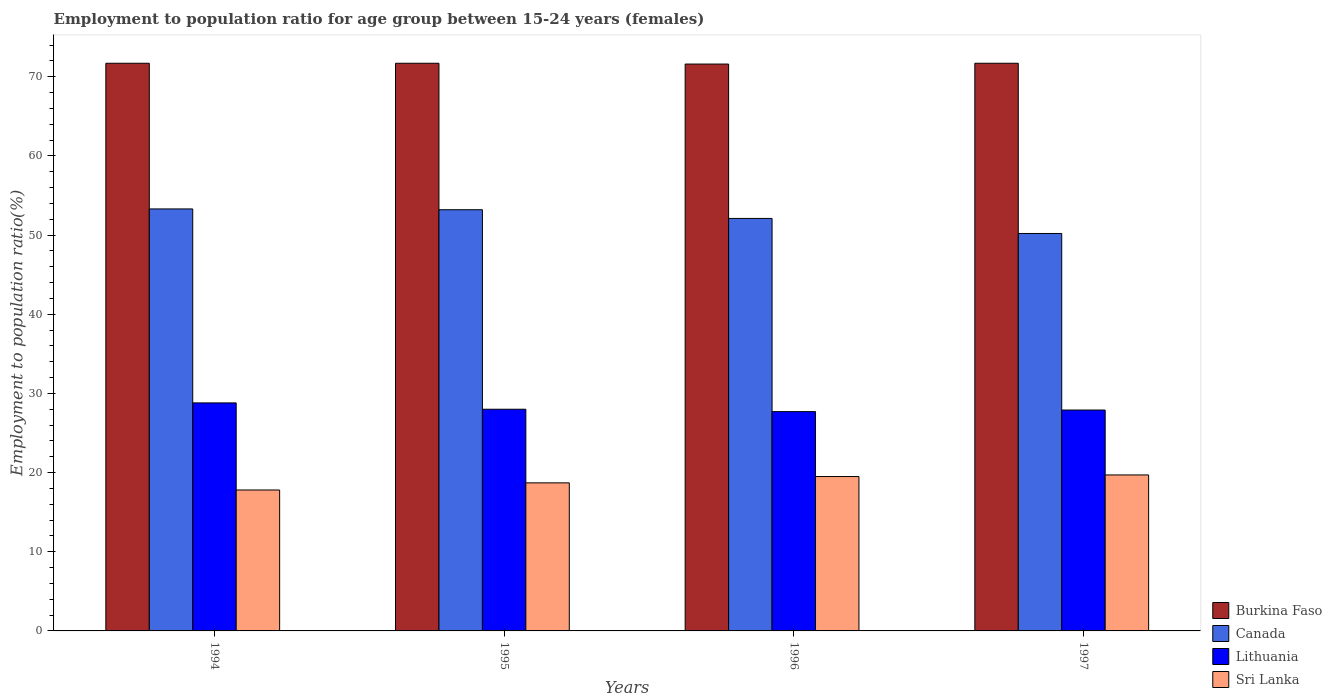Are the number of bars per tick equal to the number of legend labels?
Make the answer very short. Yes. How many bars are there on the 2nd tick from the right?
Make the answer very short. 4. What is the label of the 3rd group of bars from the left?
Keep it short and to the point. 1996. What is the employment to population ratio in Canada in 1995?
Offer a very short reply. 53.2. Across all years, what is the maximum employment to population ratio in Burkina Faso?
Provide a succinct answer. 71.7. Across all years, what is the minimum employment to population ratio in Sri Lanka?
Your answer should be compact. 17.8. In which year was the employment to population ratio in Burkina Faso maximum?
Provide a short and direct response. 1994. In which year was the employment to population ratio in Sri Lanka minimum?
Offer a very short reply. 1994. What is the total employment to population ratio in Lithuania in the graph?
Make the answer very short. 112.4. What is the difference between the employment to population ratio in Burkina Faso in 1995 and that in 1997?
Your answer should be very brief. 0. What is the difference between the employment to population ratio in Burkina Faso in 1997 and the employment to population ratio in Sri Lanka in 1995?
Your answer should be very brief. 53. What is the average employment to population ratio in Lithuania per year?
Keep it short and to the point. 28.1. In the year 1996, what is the difference between the employment to population ratio in Burkina Faso and employment to population ratio in Lithuania?
Keep it short and to the point. 43.9. What is the ratio of the employment to population ratio in Sri Lanka in 1994 to that in 1995?
Your answer should be compact. 0.95. What is the difference between the highest and the second highest employment to population ratio in Lithuania?
Keep it short and to the point. 0.8. What is the difference between the highest and the lowest employment to population ratio in Canada?
Make the answer very short. 3.1. Is the sum of the employment to population ratio in Burkina Faso in 1995 and 1996 greater than the maximum employment to population ratio in Sri Lanka across all years?
Offer a terse response. Yes. Is it the case that in every year, the sum of the employment to population ratio in Canada and employment to population ratio in Burkina Faso is greater than the sum of employment to population ratio in Sri Lanka and employment to population ratio in Lithuania?
Offer a very short reply. Yes. What does the 4th bar from the right in 1996 represents?
Ensure brevity in your answer.  Burkina Faso. Are all the bars in the graph horizontal?
Ensure brevity in your answer.  No. Are the values on the major ticks of Y-axis written in scientific E-notation?
Offer a terse response. No. Does the graph contain any zero values?
Ensure brevity in your answer.  No. Does the graph contain grids?
Give a very brief answer. No. Where does the legend appear in the graph?
Provide a short and direct response. Bottom right. How are the legend labels stacked?
Keep it short and to the point. Vertical. What is the title of the graph?
Keep it short and to the point. Employment to population ratio for age group between 15-24 years (females). What is the label or title of the Y-axis?
Provide a short and direct response. Employment to population ratio(%). What is the Employment to population ratio(%) in Burkina Faso in 1994?
Offer a terse response. 71.7. What is the Employment to population ratio(%) of Canada in 1994?
Your response must be concise. 53.3. What is the Employment to population ratio(%) in Lithuania in 1994?
Ensure brevity in your answer.  28.8. What is the Employment to population ratio(%) of Sri Lanka in 1994?
Keep it short and to the point. 17.8. What is the Employment to population ratio(%) of Burkina Faso in 1995?
Your answer should be very brief. 71.7. What is the Employment to population ratio(%) of Canada in 1995?
Your response must be concise. 53.2. What is the Employment to population ratio(%) in Sri Lanka in 1995?
Your answer should be compact. 18.7. What is the Employment to population ratio(%) in Burkina Faso in 1996?
Provide a short and direct response. 71.6. What is the Employment to population ratio(%) in Canada in 1996?
Your answer should be compact. 52.1. What is the Employment to population ratio(%) of Lithuania in 1996?
Provide a short and direct response. 27.7. What is the Employment to population ratio(%) in Sri Lanka in 1996?
Keep it short and to the point. 19.5. What is the Employment to population ratio(%) of Burkina Faso in 1997?
Give a very brief answer. 71.7. What is the Employment to population ratio(%) in Canada in 1997?
Make the answer very short. 50.2. What is the Employment to population ratio(%) in Lithuania in 1997?
Ensure brevity in your answer.  27.9. What is the Employment to population ratio(%) in Sri Lanka in 1997?
Your response must be concise. 19.7. Across all years, what is the maximum Employment to population ratio(%) in Burkina Faso?
Your response must be concise. 71.7. Across all years, what is the maximum Employment to population ratio(%) of Canada?
Keep it short and to the point. 53.3. Across all years, what is the maximum Employment to population ratio(%) in Lithuania?
Your answer should be very brief. 28.8. Across all years, what is the maximum Employment to population ratio(%) of Sri Lanka?
Provide a succinct answer. 19.7. Across all years, what is the minimum Employment to population ratio(%) of Burkina Faso?
Provide a succinct answer. 71.6. Across all years, what is the minimum Employment to population ratio(%) of Canada?
Offer a terse response. 50.2. Across all years, what is the minimum Employment to population ratio(%) in Lithuania?
Provide a succinct answer. 27.7. Across all years, what is the minimum Employment to population ratio(%) of Sri Lanka?
Give a very brief answer. 17.8. What is the total Employment to population ratio(%) in Burkina Faso in the graph?
Your answer should be compact. 286.7. What is the total Employment to population ratio(%) of Canada in the graph?
Your answer should be very brief. 208.8. What is the total Employment to population ratio(%) of Lithuania in the graph?
Provide a short and direct response. 112.4. What is the total Employment to population ratio(%) in Sri Lanka in the graph?
Provide a succinct answer. 75.7. What is the difference between the Employment to population ratio(%) in Canada in 1994 and that in 1995?
Offer a very short reply. 0.1. What is the difference between the Employment to population ratio(%) of Lithuania in 1994 and that in 1995?
Your response must be concise. 0.8. What is the difference between the Employment to population ratio(%) in Burkina Faso in 1994 and that in 1996?
Give a very brief answer. 0.1. What is the difference between the Employment to population ratio(%) in Burkina Faso in 1994 and that in 1997?
Offer a terse response. 0. What is the difference between the Employment to population ratio(%) in Canada in 1994 and that in 1997?
Ensure brevity in your answer.  3.1. What is the difference between the Employment to population ratio(%) in Sri Lanka in 1994 and that in 1997?
Offer a terse response. -1.9. What is the difference between the Employment to population ratio(%) in Burkina Faso in 1995 and that in 1996?
Ensure brevity in your answer.  0.1. What is the difference between the Employment to population ratio(%) of Sri Lanka in 1995 and that in 1997?
Your response must be concise. -1. What is the difference between the Employment to population ratio(%) in Burkina Faso in 1996 and that in 1997?
Offer a very short reply. -0.1. What is the difference between the Employment to population ratio(%) in Burkina Faso in 1994 and the Employment to population ratio(%) in Lithuania in 1995?
Make the answer very short. 43.7. What is the difference between the Employment to population ratio(%) in Burkina Faso in 1994 and the Employment to population ratio(%) in Sri Lanka in 1995?
Offer a terse response. 53. What is the difference between the Employment to population ratio(%) in Canada in 1994 and the Employment to population ratio(%) in Lithuania in 1995?
Give a very brief answer. 25.3. What is the difference between the Employment to population ratio(%) of Canada in 1994 and the Employment to population ratio(%) of Sri Lanka in 1995?
Provide a succinct answer. 34.6. What is the difference between the Employment to population ratio(%) of Burkina Faso in 1994 and the Employment to population ratio(%) of Canada in 1996?
Your response must be concise. 19.6. What is the difference between the Employment to population ratio(%) in Burkina Faso in 1994 and the Employment to population ratio(%) in Sri Lanka in 1996?
Your answer should be very brief. 52.2. What is the difference between the Employment to population ratio(%) in Canada in 1994 and the Employment to population ratio(%) in Lithuania in 1996?
Keep it short and to the point. 25.6. What is the difference between the Employment to population ratio(%) of Canada in 1994 and the Employment to population ratio(%) of Sri Lanka in 1996?
Your answer should be very brief. 33.8. What is the difference between the Employment to population ratio(%) of Lithuania in 1994 and the Employment to population ratio(%) of Sri Lanka in 1996?
Your response must be concise. 9.3. What is the difference between the Employment to population ratio(%) of Burkina Faso in 1994 and the Employment to population ratio(%) of Lithuania in 1997?
Give a very brief answer. 43.8. What is the difference between the Employment to population ratio(%) in Canada in 1994 and the Employment to population ratio(%) in Lithuania in 1997?
Offer a very short reply. 25.4. What is the difference between the Employment to population ratio(%) in Canada in 1994 and the Employment to population ratio(%) in Sri Lanka in 1997?
Offer a very short reply. 33.6. What is the difference between the Employment to population ratio(%) in Burkina Faso in 1995 and the Employment to population ratio(%) in Canada in 1996?
Provide a short and direct response. 19.6. What is the difference between the Employment to population ratio(%) of Burkina Faso in 1995 and the Employment to population ratio(%) of Lithuania in 1996?
Your answer should be compact. 44. What is the difference between the Employment to population ratio(%) in Burkina Faso in 1995 and the Employment to population ratio(%) in Sri Lanka in 1996?
Keep it short and to the point. 52.2. What is the difference between the Employment to population ratio(%) of Canada in 1995 and the Employment to population ratio(%) of Sri Lanka in 1996?
Your answer should be compact. 33.7. What is the difference between the Employment to population ratio(%) in Lithuania in 1995 and the Employment to population ratio(%) in Sri Lanka in 1996?
Give a very brief answer. 8.5. What is the difference between the Employment to population ratio(%) of Burkina Faso in 1995 and the Employment to population ratio(%) of Canada in 1997?
Ensure brevity in your answer.  21.5. What is the difference between the Employment to population ratio(%) of Burkina Faso in 1995 and the Employment to population ratio(%) of Lithuania in 1997?
Provide a succinct answer. 43.8. What is the difference between the Employment to population ratio(%) in Canada in 1995 and the Employment to population ratio(%) in Lithuania in 1997?
Keep it short and to the point. 25.3. What is the difference between the Employment to population ratio(%) in Canada in 1995 and the Employment to population ratio(%) in Sri Lanka in 1997?
Offer a very short reply. 33.5. What is the difference between the Employment to population ratio(%) of Burkina Faso in 1996 and the Employment to population ratio(%) of Canada in 1997?
Your answer should be very brief. 21.4. What is the difference between the Employment to population ratio(%) in Burkina Faso in 1996 and the Employment to population ratio(%) in Lithuania in 1997?
Your response must be concise. 43.7. What is the difference between the Employment to population ratio(%) of Burkina Faso in 1996 and the Employment to population ratio(%) of Sri Lanka in 1997?
Your answer should be compact. 51.9. What is the difference between the Employment to population ratio(%) of Canada in 1996 and the Employment to population ratio(%) of Lithuania in 1997?
Keep it short and to the point. 24.2. What is the difference between the Employment to population ratio(%) of Canada in 1996 and the Employment to population ratio(%) of Sri Lanka in 1997?
Offer a terse response. 32.4. What is the difference between the Employment to population ratio(%) of Lithuania in 1996 and the Employment to population ratio(%) of Sri Lanka in 1997?
Provide a short and direct response. 8. What is the average Employment to population ratio(%) of Burkina Faso per year?
Give a very brief answer. 71.67. What is the average Employment to population ratio(%) in Canada per year?
Make the answer very short. 52.2. What is the average Employment to population ratio(%) of Lithuania per year?
Provide a short and direct response. 28.1. What is the average Employment to population ratio(%) in Sri Lanka per year?
Your answer should be compact. 18.93. In the year 1994, what is the difference between the Employment to population ratio(%) of Burkina Faso and Employment to population ratio(%) of Canada?
Provide a short and direct response. 18.4. In the year 1994, what is the difference between the Employment to population ratio(%) of Burkina Faso and Employment to population ratio(%) of Lithuania?
Give a very brief answer. 42.9. In the year 1994, what is the difference between the Employment to population ratio(%) of Burkina Faso and Employment to population ratio(%) of Sri Lanka?
Ensure brevity in your answer.  53.9. In the year 1994, what is the difference between the Employment to population ratio(%) in Canada and Employment to population ratio(%) in Sri Lanka?
Provide a succinct answer. 35.5. In the year 1994, what is the difference between the Employment to population ratio(%) of Lithuania and Employment to population ratio(%) of Sri Lanka?
Your answer should be very brief. 11. In the year 1995, what is the difference between the Employment to population ratio(%) in Burkina Faso and Employment to population ratio(%) in Lithuania?
Your answer should be compact. 43.7. In the year 1995, what is the difference between the Employment to population ratio(%) in Canada and Employment to population ratio(%) in Lithuania?
Provide a short and direct response. 25.2. In the year 1995, what is the difference between the Employment to population ratio(%) in Canada and Employment to population ratio(%) in Sri Lanka?
Provide a short and direct response. 34.5. In the year 1996, what is the difference between the Employment to population ratio(%) in Burkina Faso and Employment to population ratio(%) in Canada?
Offer a very short reply. 19.5. In the year 1996, what is the difference between the Employment to population ratio(%) in Burkina Faso and Employment to population ratio(%) in Lithuania?
Ensure brevity in your answer.  43.9. In the year 1996, what is the difference between the Employment to population ratio(%) in Burkina Faso and Employment to population ratio(%) in Sri Lanka?
Offer a terse response. 52.1. In the year 1996, what is the difference between the Employment to population ratio(%) in Canada and Employment to population ratio(%) in Lithuania?
Your answer should be very brief. 24.4. In the year 1996, what is the difference between the Employment to population ratio(%) in Canada and Employment to population ratio(%) in Sri Lanka?
Provide a short and direct response. 32.6. In the year 1996, what is the difference between the Employment to population ratio(%) in Lithuania and Employment to population ratio(%) in Sri Lanka?
Offer a terse response. 8.2. In the year 1997, what is the difference between the Employment to population ratio(%) of Burkina Faso and Employment to population ratio(%) of Lithuania?
Offer a terse response. 43.8. In the year 1997, what is the difference between the Employment to population ratio(%) in Canada and Employment to population ratio(%) in Lithuania?
Keep it short and to the point. 22.3. In the year 1997, what is the difference between the Employment to population ratio(%) in Canada and Employment to population ratio(%) in Sri Lanka?
Ensure brevity in your answer.  30.5. In the year 1997, what is the difference between the Employment to population ratio(%) of Lithuania and Employment to population ratio(%) of Sri Lanka?
Offer a terse response. 8.2. What is the ratio of the Employment to population ratio(%) in Canada in 1994 to that in 1995?
Offer a very short reply. 1. What is the ratio of the Employment to population ratio(%) in Lithuania in 1994 to that in 1995?
Your answer should be compact. 1.03. What is the ratio of the Employment to population ratio(%) of Sri Lanka in 1994 to that in 1995?
Make the answer very short. 0.95. What is the ratio of the Employment to population ratio(%) in Burkina Faso in 1994 to that in 1996?
Ensure brevity in your answer.  1. What is the ratio of the Employment to population ratio(%) of Canada in 1994 to that in 1996?
Your answer should be very brief. 1.02. What is the ratio of the Employment to population ratio(%) of Lithuania in 1994 to that in 1996?
Your response must be concise. 1.04. What is the ratio of the Employment to population ratio(%) in Sri Lanka in 1994 to that in 1996?
Offer a terse response. 0.91. What is the ratio of the Employment to population ratio(%) in Canada in 1994 to that in 1997?
Ensure brevity in your answer.  1.06. What is the ratio of the Employment to population ratio(%) of Lithuania in 1994 to that in 1997?
Provide a succinct answer. 1.03. What is the ratio of the Employment to population ratio(%) of Sri Lanka in 1994 to that in 1997?
Your answer should be very brief. 0.9. What is the ratio of the Employment to population ratio(%) in Canada in 1995 to that in 1996?
Provide a succinct answer. 1.02. What is the ratio of the Employment to population ratio(%) of Lithuania in 1995 to that in 1996?
Make the answer very short. 1.01. What is the ratio of the Employment to population ratio(%) of Sri Lanka in 1995 to that in 1996?
Ensure brevity in your answer.  0.96. What is the ratio of the Employment to population ratio(%) of Canada in 1995 to that in 1997?
Provide a succinct answer. 1.06. What is the ratio of the Employment to population ratio(%) in Lithuania in 1995 to that in 1997?
Provide a succinct answer. 1. What is the ratio of the Employment to population ratio(%) in Sri Lanka in 1995 to that in 1997?
Give a very brief answer. 0.95. What is the ratio of the Employment to population ratio(%) in Burkina Faso in 1996 to that in 1997?
Offer a very short reply. 1. What is the ratio of the Employment to population ratio(%) of Canada in 1996 to that in 1997?
Give a very brief answer. 1.04. What is the ratio of the Employment to population ratio(%) of Lithuania in 1996 to that in 1997?
Ensure brevity in your answer.  0.99. What is the ratio of the Employment to population ratio(%) of Sri Lanka in 1996 to that in 1997?
Provide a short and direct response. 0.99. What is the difference between the highest and the second highest Employment to population ratio(%) in Burkina Faso?
Keep it short and to the point. 0. What is the difference between the highest and the second highest Employment to population ratio(%) of Canada?
Provide a succinct answer. 0.1. What is the difference between the highest and the second highest Employment to population ratio(%) in Lithuania?
Your answer should be compact. 0.8. What is the difference between the highest and the lowest Employment to population ratio(%) in Sri Lanka?
Offer a terse response. 1.9. 